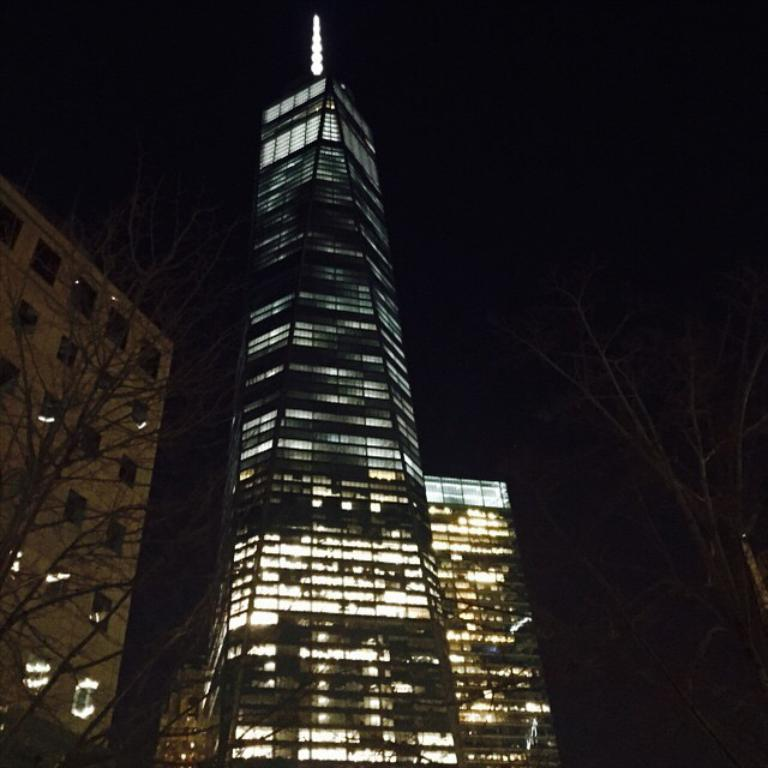What type of vegetation is present on both sides of the image? There are trees on either side of the image. What structures are located in the middle of the image? There are buildings with lights in the middle of the image. What can be seen at the top of the image? The sky is visible at the top of the image. What type of current can be seen flowing through the trees in the image? There is no current visible in the image. 